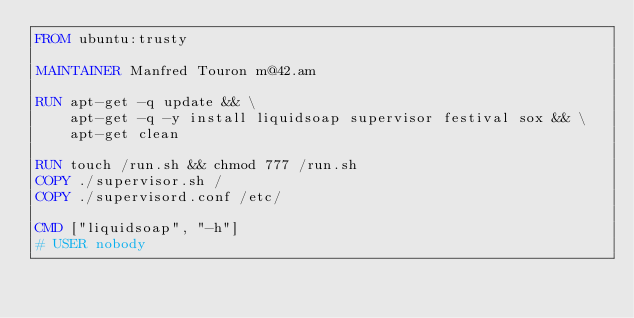Convert code to text. <code><loc_0><loc_0><loc_500><loc_500><_Dockerfile_>FROM ubuntu:trusty

MAINTAINER Manfred Touron m@42.am

RUN apt-get -q update && \
    apt-get -q -y install liquidsoap supervisor festival sox && \
    apt-get clean

RUN touch /run.sh && chmod 777 /run.sh
COPY ./supervisor.sh /
COPY ./supervisord.conf /etc/

CMD ["liquidsoap", "-h"]
# USER nobody
</code> 